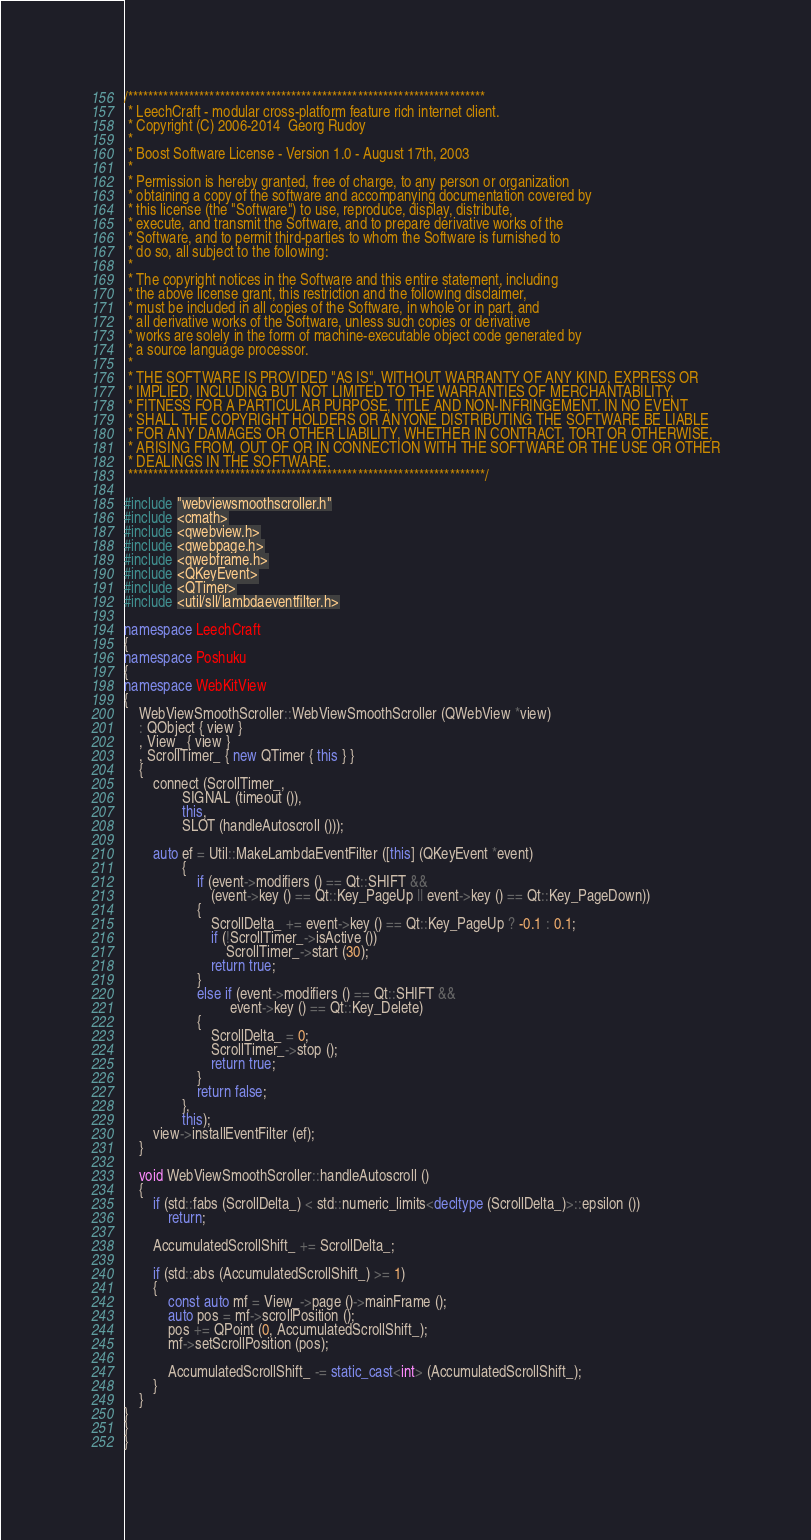<code> <loc_0><loc_0><loc_500><loc_500><_C++_>/**********************************************************************
 * LeechCraft - modular cross-platform feature rich internet client.
 * Copyright (C) 2006-2014  Georg Rudoy
 *
 * Boost Software License - Version 1.0 - August 17th, 2003
 *
 * Permission is hereby granted, free of charge, to any person or organization
 * obtaining a copy of the software and accompanying documentation covered by
 * this license (the "Software") to use, reproduce, display, distribute,
 * execute, and transmit the Software, and to prepare derivative works of the
 * Software, and to permit third-parties to whom the Software is furnished to
 * do so, all subject to the following:
 *
 * The copyright notices in the Software and this entire statement, including
 * the above license grant, this restriction and the following disclaimer,
 * must be included in all copies of the Software, in whole or in part, and
 * all derivative works of the Software, unless such copies or derivative
 * works are solely in the form of machine-executable object code generated by
 * a source language processor.
 *
 * THE SOFTWARE IS PROVIDED "AS IS", WITHOUT WARRANTY OF ANY KIND, EXPRESS OR
 * IMPLIED, INCLUDING BUT NOT LIMITED TO THE WARRANTIES OF MERCHANTABILITY,
 * FITNESS FOR A PARTICULAR PURPOSE, TITLE AND NON-INFRINGEMENT. IN NO EVENT
 * SHALL THE COPYRIGHT HOLDERS OR ANYONE DISTRIBUTING THE SOFTWARE BE LIABLE
 * FOR ANY DAMAGES OR OTHER LIABILITY, WHETHER IN CONTRACT, TORT OR OTHERWISE,
 * ARISING FROM, OUT OF OR IN CONNECTION WITH THE SOFTWARE OR THE USE OR OTHER
 * DEALINGS IN THE SOFTWARE.
 **********************************************************************/

#include "webviewsmoothscroller.h"
#include <cmath>
#include <qwebview.h>
#include <qwebpage.h>
#include <qwebframe.h>
#include <QKeyEvent>
#include <QTimer>
#include <util/sll/lambdaeventfilter.h>

namespace LeechCraft
{
namespace Poshuku
{
namespace WebKitView
{
	WebViewSmoothScroller::WebViewSmoothScroller (QWebView *view)
	: QObject { view }
	, View_ { view }
	, ScrollTimer_ { new QTimer { this } }
	{
		connect (ScrollTimer_,
				SIGNAL (timeout ()),
				this,
				SLOT (handleAutoscroll ()));

		auto ef = Util::MakeLambdaEventFilter ([this] (QKeyEvent *event)
				{
					if (event->modifiers () == Qt::SHIFT &&
						(event->key () == Qt::Key_PageUp || event->key () == Qt::Key_PageDown))
					{
						ScrollDelta_ += event->key () == Qt::Key_PageUp ? -0.1 : 0.1;
						if (!ScrollTimer_->isActive ())
							ScrollTimer_->start (30);
						return true;
					}
					else if (event->modifiers () == Qt::SHIFT &&
							 event->key () == Qt::Key_Delete)
					{
						ScrollDelta_ = 0;
						ScrollTimer_->stop ();
						return true;
					}
					return false;
				},
				this);
		view->installEventFilter (ef);
	}

	void WebViewSmoothScroller::handleAutoscroll ()
	{
		if (std::fabs (ScrollDelta_) < std::numeric_limits<decltype (ScrollDelta_)>::epsilon ())
			return;

		AccumulatedScrollShift_ += ScrollDelta_;

		if (std::abs (AccumulatedScrollShift_) >= 1)
		{
			const auto mf = View_->page ()->mainFrame ();
			auto pos = mf->scrollPosition ();
			pos += QPoint (0, AccumulatedScrollShift_);
			mf->setScrollPosition (pos);

			AccumulatedScrollShift_ -= static_cast<int> (AccumulatedScrollShift_);
		}
	}
}
}
}
</code> 